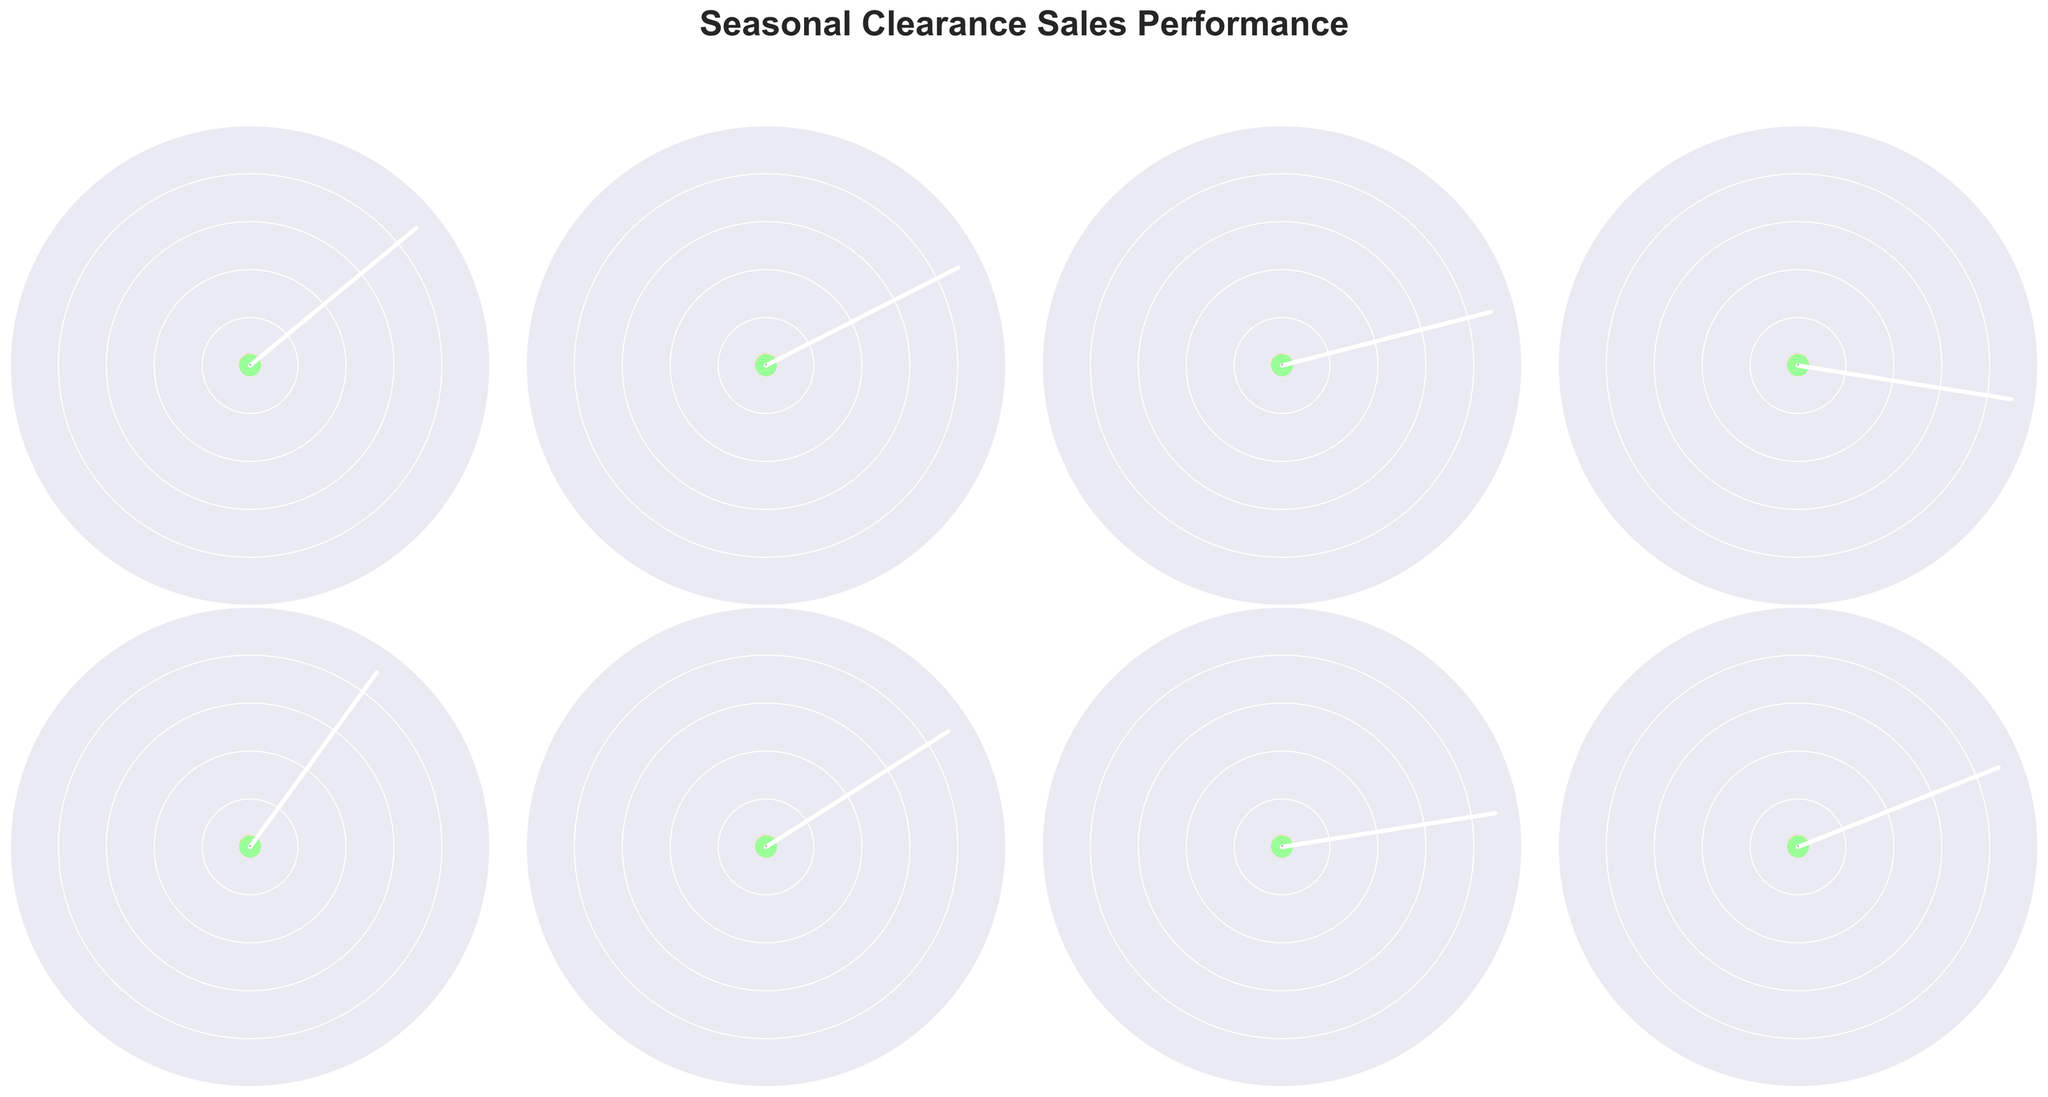What's the title of the figure? The title of the figure can be found at the top. It reads "Seasonal Clearance Sales Performance".
Answer: Seasonal Clearance Sales Performance How many categories are displayed in the figure? By looking at the different gauge charts, we can count a total of 8 categories.
Answer: 8 Which category had the highest percentage of inventory sold? Observing the needle positions, Patio & Outdoor has the highest value at 80%.
Answer: Patio & Outdoor What is the average percentage of inventory sold across all categories? Add up all the percentages and divide by the number of categories: (72 + 65 + 58 + 45 + 80 + 68 + 55 + 62) / 8 = 63.125%.
Answer: 63.125% What is the percentage difference between the category with the highest and the lowest percentage sold? The highest percentage is 80% (Patio & Outdoor) and the lowest is 45% (Office Furniture). Calculate the difference: 80% - 45% = 35%.
Answer: 35% Which category has a percentage of inventory sold below 50%? Reviewing the gauge charts, only Office Furniture is below 50% at 45%.
Answer: Office Furniture How many categories have a percentage of inventory sold above 60%? Count the number of categories with percentages above 60%: Living Room Furniture, Bedroom Sets, Patio & Outdoor, Home Decor, and Kids Furniture making a total of 5.
Answer: 5 Which two categories have the closest percentage of inventory sold, and what is the difference? Kids Furniture and Bedroom Sets have percentages close to each other at 62% and 65%. The difference is 65% - 62% = 3%.
Answer: Kids Furniture and Bedroom Sets, 3% Which categories have a percentage of inventory sold between 55% and 70%? Identifying the categories within this range: Bedroom Sets (65%), Dining Room Furniture (58%), Home Decor (68%), Mattresses (55%), and Kids Furniture (62%).
Answer: Bedroom Sets, Dining Room Furniture, Home Decor, Mattresses, Kids Furniture 